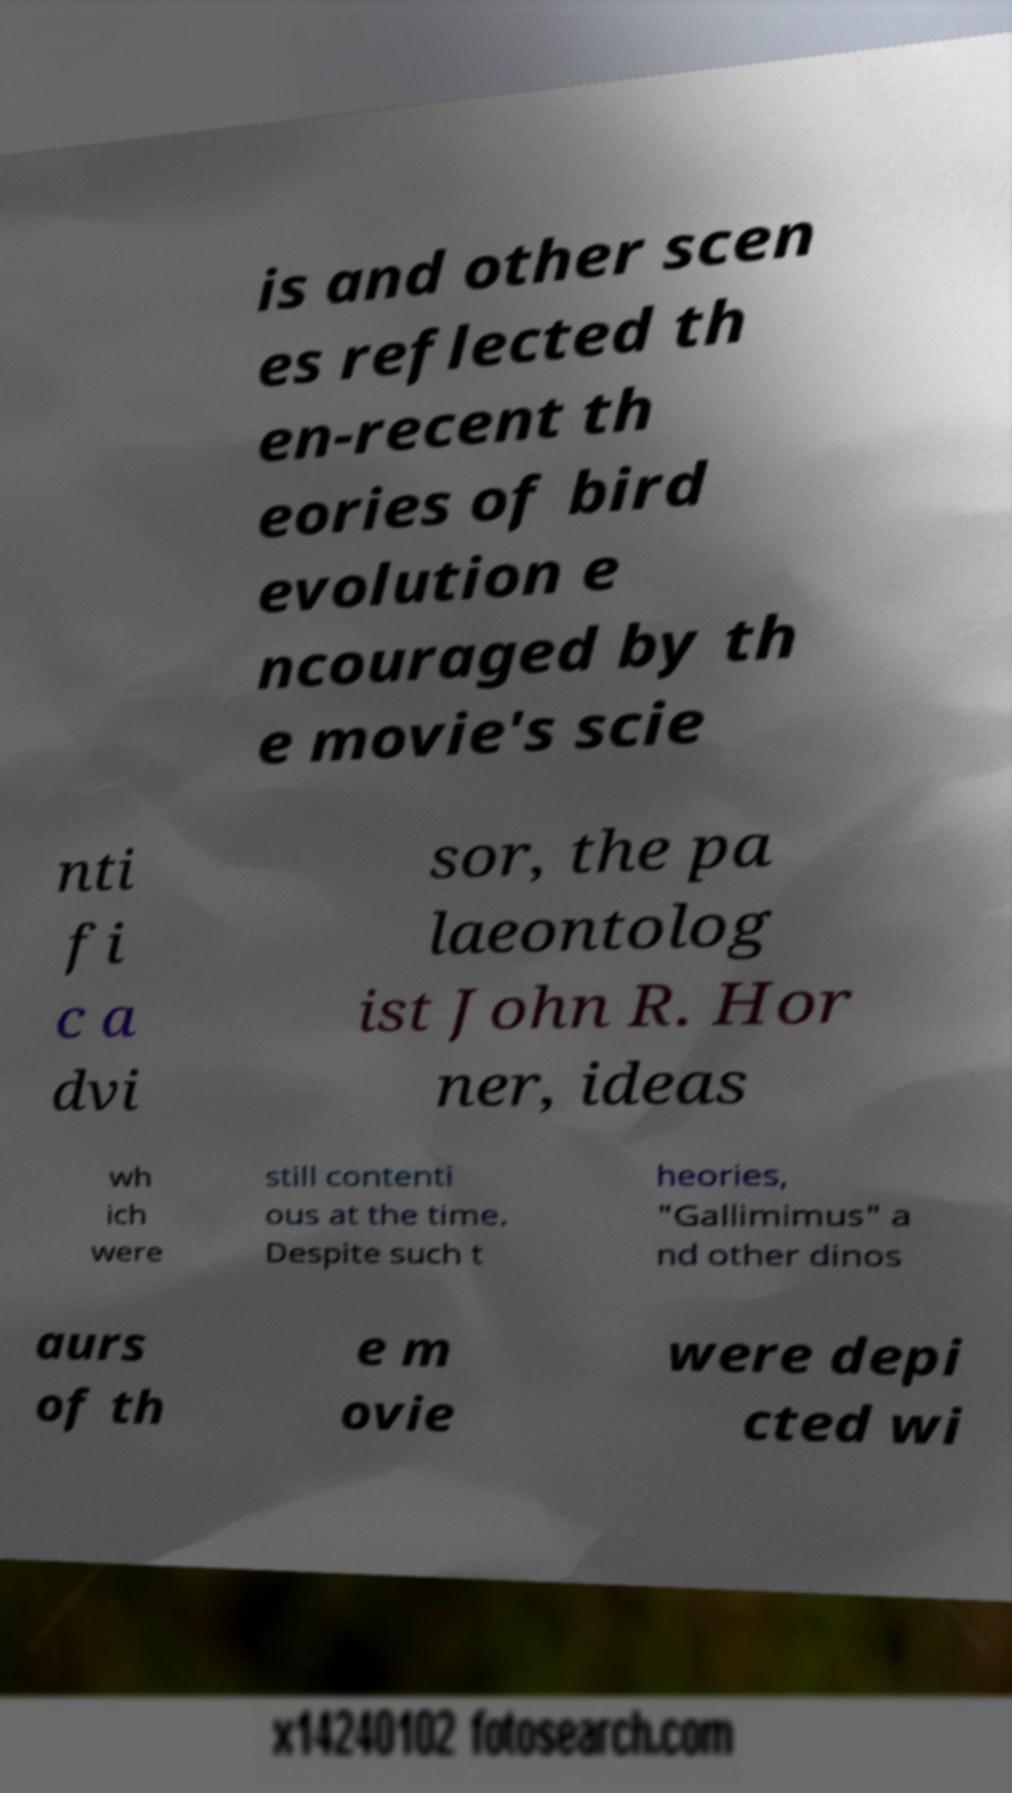Please identify and transcribe the text found in this image. is and other scen es reflected th en-recent th eories of bird evolution e ncouraged by th e movie's scie nti fi c a dvi sor, the pa laeontolog ist John R. Hor ner, ideas wh ich were still contenti ous at the time. Despite such t heories, "Gallimimus" a nd other dinos aurs of th e m ovie were depi cted wi 